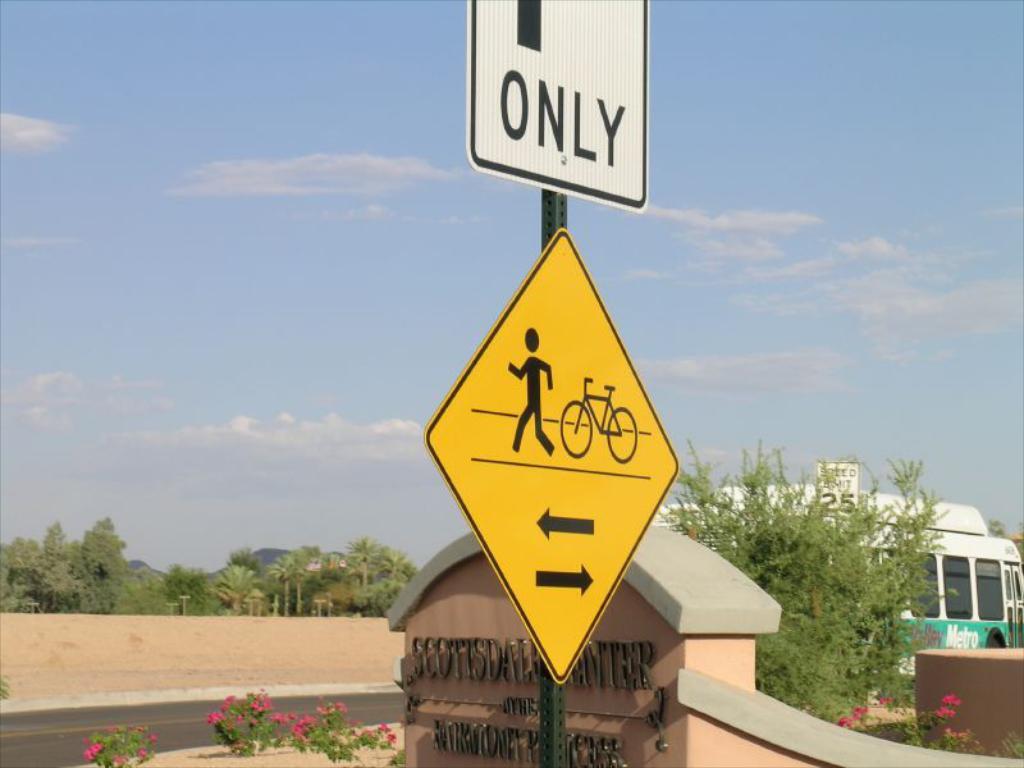What does the sign say?
Your answer should be compact. Only. 